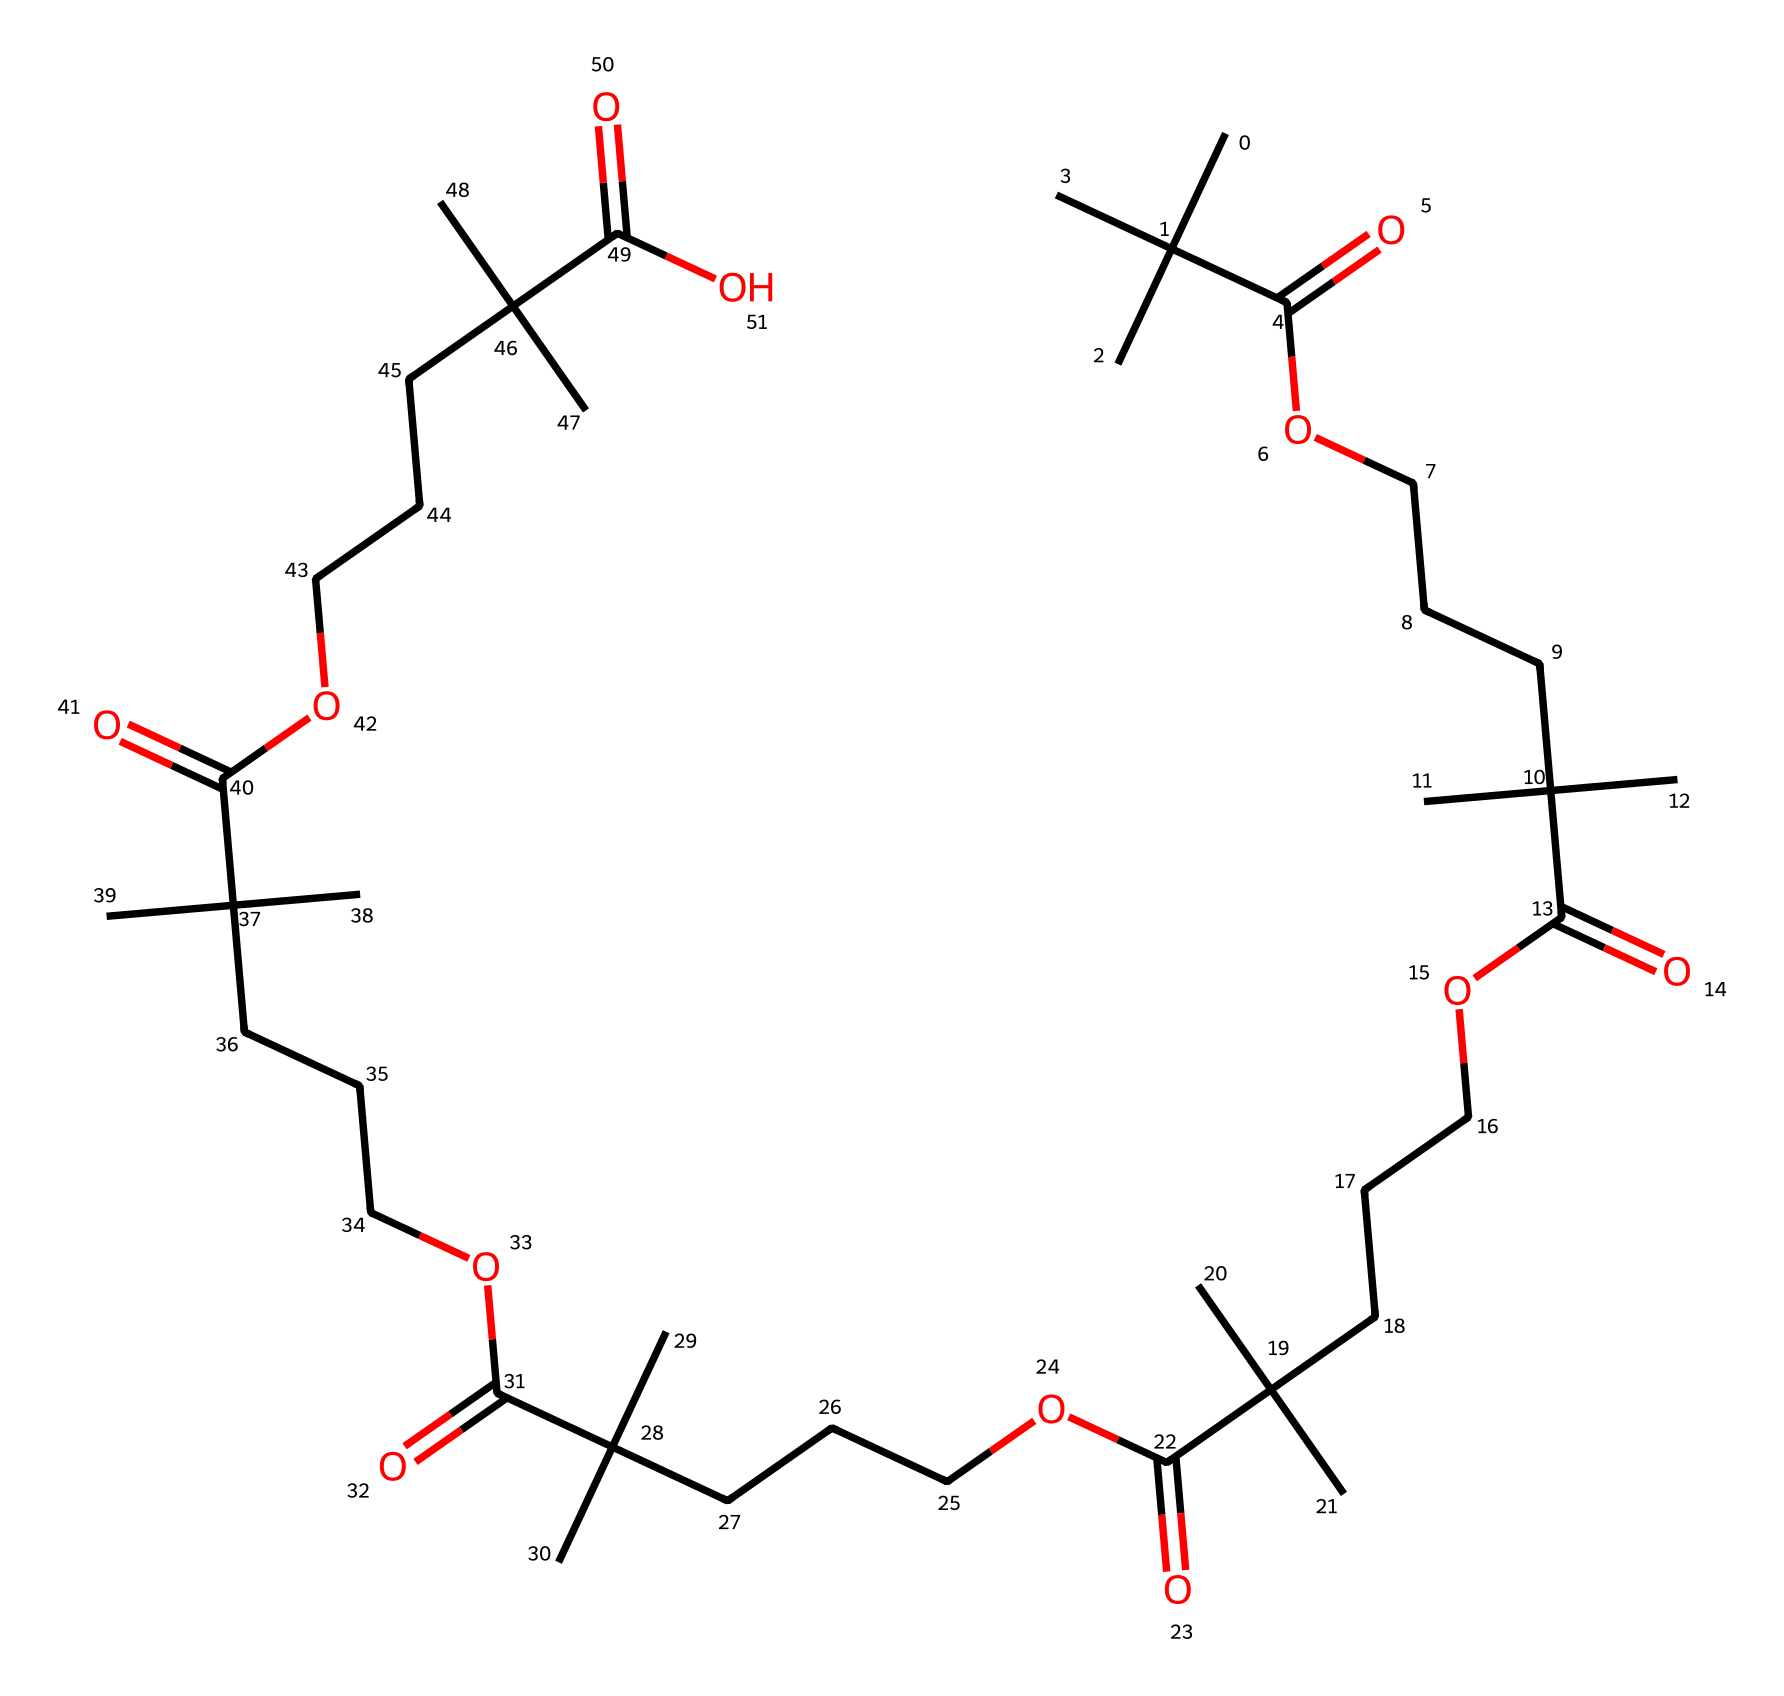What is the molecular formula of the chemical? To determine the molecular formula, we count the number of carbon (C), hydrogen (H), and oxygen (O) atoms present in the SMILES notation. The structure suggests a repetitive unit with a total of 30 carbon atoms, 54 hydrogen atoms, and 6 oxygen atoms.
Answer: C30H54O6 How many carbon atoms are present in the molecule? By analyzing the SMILES representation, we count the number of carbon atoms in the structure. In total, there are 30 carbon atoms.
Answer: 30 What type of functional groups are present in the chemical? The SMILES representation indicates the presence of carboxylic acid functional groups due to the C(=O)O sections observed. Each of these segments corresponds to COOH groups.
Answer: carboxylic acids What is the expected solubility behavior of this polymer in water? Given the presence of multiple hydrophobic alkyl chains and carboxylic acid groups, the molecule exhibits amphiphilic characteristics. However, the dominance of hydrophobic regions suggests lower solubility in water.
Answer: low solubility How does the repetitive structure contribute to self-healing properties? The repetitive backbone structure can enhance the material's flexibility and elasticity, enabling the polymer to return to its original shape when damaged. This property is critical for self-healing mechanisms, allowing for the reformation of covalent or ionic bonds after stress.
Answer: enhances flexibility What type of interactions can you expect between the polymer chains? The presence of carboxylic acid groups suggests that hydrogen bonding and van der Waals interactions will dominate. These interactions contribute to the polymer's overall mechanical strength and longevity in automotive applications.
Answer: hydrogen bonding, van der Waals interactions 